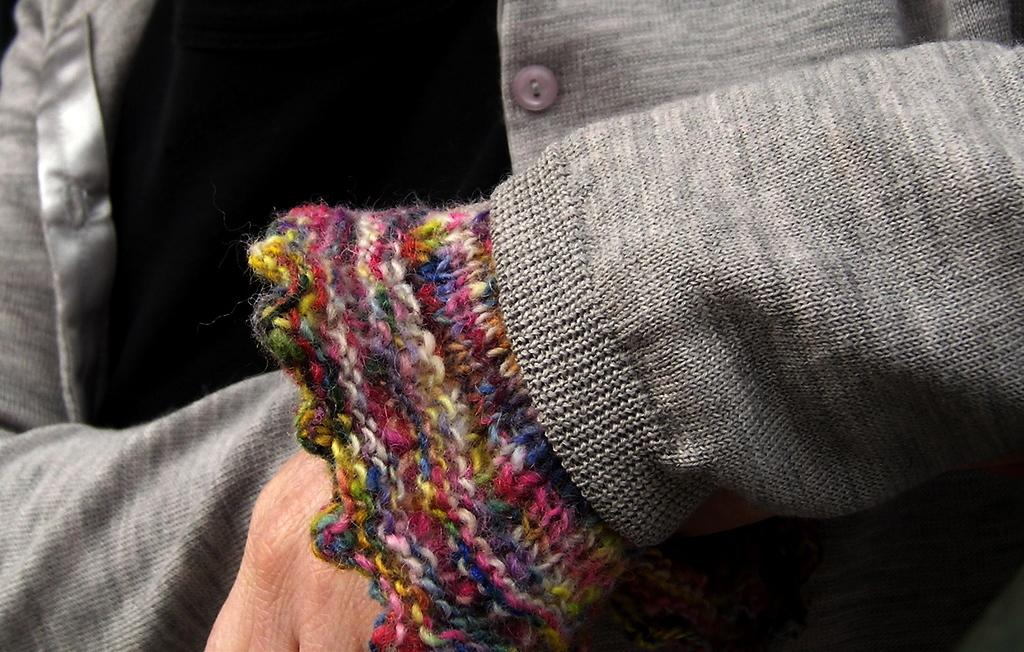What is present in the image? There is a person in the image. Can you describe the person's appearance? The person's face is not visible in the image. What is the person wearing? The person is wearing a coat. What type of pie is the person holding in the image? There is no pie present in the image; the person is wearing a coat and their face is not visible. 